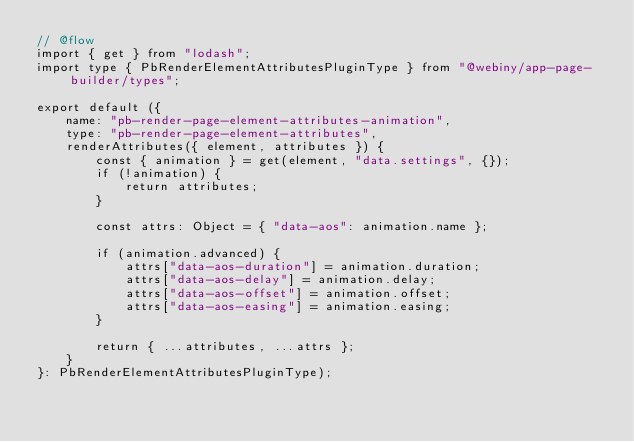<code> <loc_0><loc_0><loc_500><loc_500><_JavaScript_>// @flow
import { get } from "lodash";
import type { PbRenderElementAttributesPluginType } from "@webiny/app-page-builder/types";

export default ({
    name: "pb-render-page-element-attributes-animation",
    type: "pb-render-page-element-attributes",
    renderAttributes({ element, attributes }) {
        const { animation } = get(element, "data.settings", {});
        if (!animation) {
            return attributes;
        }

        const attrs: Object = { "data-aos": animation.name };

        if (animation.advanced) {
            attrs["data-aos-duration"] = animation.duration;
            attrs["data-aos-delay"] = animation.delay;
            attrs["data-aos-offset"] = animation.offset;
            attrs["data-aos-easing"] = animation.easing;
        }

        return { ...attributes, ...attrs };
    }
}: PbRenderElementAttributesPluginType);
</code> 